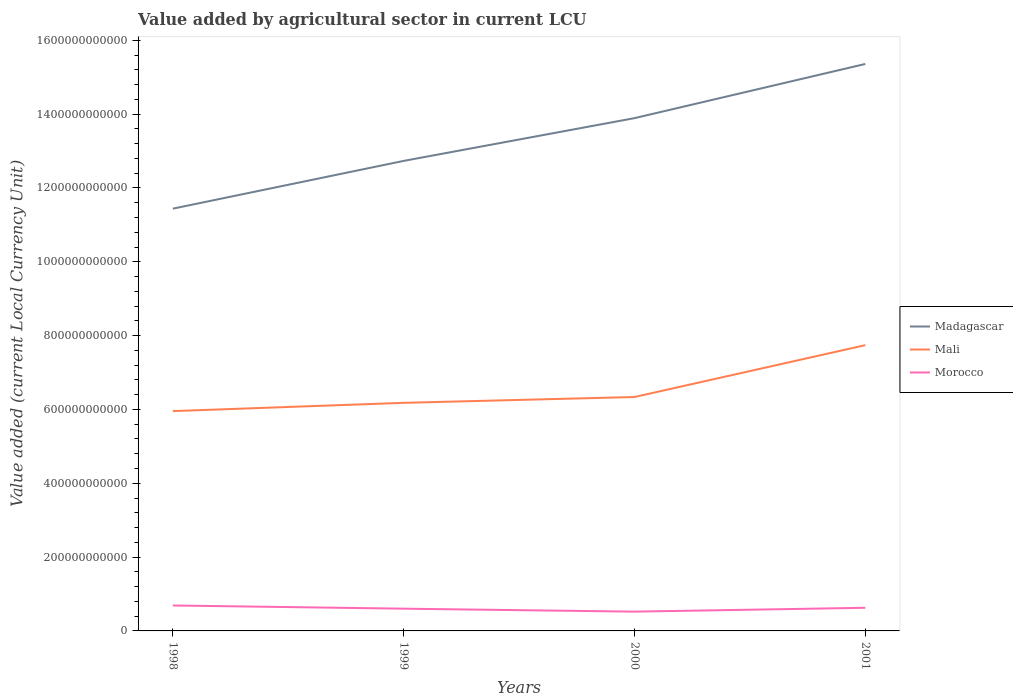Does the line corresponding to Morocco intersect with the line corresponding to Mali?
Make the answer very short. No. Across all years, what is the maximum value added by agricultural sector in Madagascar?
Your answer should be compact. 1.14e+12. In which year was the value added by agricultural sector in Madagascar maximum?
Provide a short and direct response. 1998. What is the total value added by agricultural sector in Morocco in the graph?
Provide a succinct answer. 1.67e+1. What is the difference between the highest and the second highest value added by agricultural sector in Mali?
Keep it short and to the point. 1.79e+11. What is the difference between the highest and the lowest value added by agricultural sector in Mali?
Keep it short and to the point. 1. Is the value added by agricultural sector in Madagascar strictly greater than the value added by agricultural sector in Mali over the years?
Your response must be concise. No. What is the difference between two consecutive major ticks on the Y-axis?
Your answer should be compact. 2.00e+11. Are the values on the major ticks of Y-axis written in scientific E-notation?
Keep it short and to the point. No. How many legend labels are there?
Make the answer very short. 3. What is the title of the graph?
Provide a short and direct response. Value added by agricultural sector in current LCU. Does "Cote d'Ivoire" appear as one of the legend labels in the graph?
Your answer should be very brief. No. What is the label or title of the X-axis?
Make the answer very short. Years. What is the label or title of the Y-axis?
Provide a short and direct response. Value added (current Local Currency Unit). What is the Value added (current Local Currency Unit) of Madagascar in 1998?
Your response must be concise. 1.14e+12. What is the Value added (current Local Currency Unit) in Mali in 1998?
Give a very brief answer. 5.95e+11. What is the Value added (current Local Currency Unit) of Morocco in 1998?
Give a very brief answer. 6.89e+1. What is the Value added (current Local Currency Unit) of Madagascar in 1999?
Your answer should be very brief. 1.27e+12. What is the Value added (current Local Currency Unit) in Mali in 1999?
Your response must be concise. 6.18e+11. What is the Value added (current Local Currency Unit) in Morocco in 1999?
Provide a succinct answer. 6.03e+1. What is the Value added (current Local Currency Unit) in Madagascar in 2000?
Make the answer very short. 1.39e+12. What is the Value added (current Local Currency Unit) of Mali in 2000?
Give a very brief answer. 6.34e+11. What is the Value added (current Local Currency Unit) of Morocco in 2000?
Provide a short and direct response. 5.22e+1. What is the Value added (current Local Currency Unit) of Madagascar in 2001?
Give a very brief answer. 1.54e+12. What is the Value added (current Local Currency Unit) of Mali in 2001?
Offer a very short reply. 7.74e+11. What is the Value added (current Local Currency Unit) in Morocco in 2001?
Ensure brevity in your answer.  6.27e+1. Across all years, what is the maximum Value added (current Local Currency Unit) in Madagascar?
Make the answer very short. 1.54e+12. Across all years, what is the maximum Value added (current Local Currency Unit) in Mali?
Your answer should be compact. 7.74e+11. Across all years, what is the maximum Value added (current Local Currency Unit) of Morocco?
Ensure brevity in your answer.  6.89e+1. Across all years, what is the minimum Value added (current Local Currency Unit) of Madagascar?
Your response must be concise. 1.14e+12. Across all years, what is the minimum Value added (current Local Currency Unit) in Mali?
Make the answer very short. 5.95e+11. Across all years, what is the minimum Value added (current Local Currency Unit) in Morocco?
Offer a terse response. 5.22e+1. What is the total Value added (current Local Currency Unit) in Madagascar in the graph?
Your response must be concise. 5.34e+12. What is the total Value added (current Local Currency Unit) of Mali in the graph?
Your answer should be compact. 2.62e+12. What is the total Value added (current Local Currency Unit) of Morocco in the graph?
Your response must be concise. 2.44e+11. What is the difference between the Value added (current Local Currency Unit) of Madagascar in 1998 and that in 1999?
Your response must be concise. -1.29e+11. What is the difference between the Value added (current Local Currency Unit) in Mali in 1998 and that in 1999?
Provide a succinct answer. -2.25e+1. What is the difference between the Value added (current Local Currency Unit) in Morocco in 1998 and that in 1999?
Keep it short and to the point. 8.63e+09. What is the difference between the Value added (current Local Currency Unit) in Madagascar in 1998 and that in 2000?
Give a very brief answer. -2.45e+11. What is the difference between the Value added (current Local Currency Unit) in Mali in 1998 and that in 2000?
Your answer should be very brief. -3.82e+1. What is the difference between the Value added (current Local Currency Unit) of Morocco in 1998 and that in 2000?
Provide a succinct answer. 1.67e+1. What is the difference between the Value added (current Local Currency Unit) of Madagascar in 1998 and that in 2001?
Your response must be concise. -3.92e+11. What is the difference between the Value added (current Local Currency Unit) of Mali in 1998 and that in 2001?
Your answer should be very brief. -1.79e+11. What is the difference between the Value added (current Local Currency Unit) in Morocco in 1998 and that in 2001?
Make the answer very short. 6.24e+09. What is the difference between the Value added (current Local Currency Unit) of Madagascar in 1999 and that in 2000?
Make the answer very short. -1.16e+11. What is the difference between the Value added (current Local Currency Unit) in Mali in 1999 and that in 2000?
Provide a succinct answer. -1.57e+1. What is the difference between the Value added (current Local Currency Unit) in Morocco in 1999 and that in 2000?
Ensure brevity in your answer.  8.05e+09. What is the difference between the Value added (current Local Currency Unit) of Madagascar in 1999 and that in 2001?
Your answer should be very brief. -2.63e+11. What is the difference between the Value added (current Local Currency Unit) in Mali in 1999 and that in 2001?
Your answer should be compact. -1.56e+11. What is the difference between the Value added (current Local Currency Unit) in Morocco in 1999 and that in 2001?
Give a very brief answer. -2.39e+09. What is the difference between the Value added (current Local Currency Unit) of Madagascar in 2000 and that in 2001?
Ensure brevity in your answer.  -1.47e+11. What is the difference between the Value added (current Local Currency Unit) of Mali in 2000 and that in 2001?
Offer a very short reply. -1.40e+11. What is the difference between the Value added (current Local Currency Unit) of Morocco in 2000 and that in 2001?
Offer a very short reply. -1.04e+1. What is the difference between the Value added (current Local Currency Unit) in Madagascar in 1998 and the Value added (current Local Currency Unit) in Mali in 1999?
Provide a succinct answer. 5.26e+11. What is the difference between the Value added (current Local Currency Unit) in Madagascar in 1998 and the Value added (current Local Currency Unit) in Morocco in 1999?
Offer a terse response. 1.08e+12. What is the difference between the Value added (current Local Currency Unit) of Mali in 1998 and the Value added (current Local Currency Unit) of Morocco in 1999?
Your answer should be compact. 5.35e+11. What is the difference between the Value added (current Local Currency Unit) of Madagascar in 1998 and the Value added (current Local Currency Unit) of Mali in 2000?
Provide a short and direct response. 5.10e+11. What is the difference between the Value added (current Local Currency Unit) in Madagascar in 1998 and the Value added (current Local Currency Unit) in Morocco in 2000?
Your response must be concise. 1.09e+12. What is the difference between the Value added (current Local Currency Unit) of Mali in 1998 and the Value added (current Local Currency Unit) of Morocco in 2000?
Offer a terse response. 5.43e+11. What is the difference between the Value added (current Local Currency Unit) in Madagascar in 1998 and the Value added (current Local Currency Unit) in Mali in 2001?
Your answer should be compact. 3.70e+11. What is the difference between the Value added (current Local Currency Unit) of Madagascar in 1998 and the Value added (current Local Currency Unit) of Morocco in 2001?
Ensure brevity in your answer.  1.08e+12. What is the difference between the Value added (current Local Currency Unit) in Mali in 1998 and the Value added (current Local Currency Unit) in Morocco in 2001?
Provide a succinct answer. 5.33e+11. What is the difference between the Value added (current Local Currency Unit) of Madagascar in 1999 and the Value added (current Local Currency Unit) of Mali in 2000?
Offer a terse response. 6.40e+11. What is the difference between the Value added (current Local Currency Unit) of Madagascar in 1999 and the Value added (current Local Currency Unit) of Morocco in 2000?
Offer a terse response. 1.22e+12. What is the difference between the Value added (current Local Currency Unit) in Mali in 1999 and the Value added (current Local Currency Unit) in Morocco in 2000?
Offer a very short reply. 5.66e+11. What is the difference between the Value added (current Local Currency Unit) of Madagascar in 1999 and the Value added (current Local Currency Unit) of Mali in 2001?
Your answer should be compact. 4.99e+11. What is the difference between the Value added (current Local Currency Unit) in Madagascar in 1999 and the Value added (current Local Currency Unit) in Morocco in 2001?
Offer a very short reply. 1.21e+12. What is the difference between the Value added (current Local Currency Unit) of Mali in 1999 and the Value added (current Local Currency Unit) of Morocco in 2001?
Make the answer very short. 5.55e+11. What is the difference between the Value added (current Local Currency Unit) in Madagascar in 2000 and the Value added (current Local Currency Unit) in Mali in 2001?
Your response must be concise. 6.15e+11. What is the difference between the Value added (current Local Currency Unit) of Madagascar in 2000 and the Value added (current Local Currency Unit) of Morocco in 2001?
Keep it short and to the point. 1.33e+12. What is the difference between the Value added (current Local Currency Unit) of Mali in 2000 and the Value added (current Local Currency Unit) of Morocco in 2001?
Keep it short and to the point. 5.71e+11. What is the average Value added (current Local Currency Unit) in Madagascar per year?
Provide a succinct answer. 1.34e+12. What is the average Value added (current Local Currency Unit) of Mali per year?
Offer a terse response. 6.55e+11. What is the average Value added (current Local Currency Unit) of Morocco per year?
Make the answer very short. 6.10e+1. In the year 1998, what is the difference between the Value added (current Local Currency Unit) in Madagascar and Value added (current Local Currency Unit) in Mali?
Your answer should be compact. 5.48e+11. In the year 1998, what is the difference between the Value added (current Local Currency Unit) of Madagascar and Value added (current Local Currency Unit) of Morocco?
Make the answer very short. 1.07e+12. In the year 1998, what is the difference between the Value added (current Local Currency Unit) in Mali and Value added (current Local Currency Unit) in Morocco?
Your answer should be compact. 5.27e+11. In the year 1999, what is the difference between the Value added (current Local Currency Unit) in Madagascar and Value added (current Local Currency Unit) in Mali?
Your answer should be compact. 6.55e+11. In the year 1999, what is the difference between the Value added (current Local Currency Unit) of Madagascar and Value added (current Local Currency Unit) of Morocco?
Give a very brief answer. 1.21e+12. In the year 1999, what is the difference between the Value added (current Local Currency Unit) in Mali and Value added (current Local Currency Unit) in Morocco?
Offer a terse response. 5.58e+11. In the year 2000, what is the difference between the Value added (current Local Currency Unit) in Madagascar and Value added (current Local Currency Unit) in Mali?
Offer a terse response. 7.55e+11. In the year 2000, what is the difference between the Value added (current Local Currency Unit) of Madagascar and Value added (current Local Currency Unit) of Morocco?
Offer a terse response. 1.34e+12. In the year 2000, what is the difference between the Value added (current Local Currency Unit) in Mali and Value added (current Local Currency Unit) in Morocco?
Keep it short and to the point. 5.81e+11. In the year 2001, what is the difference between the Value added (current Local Currency Unit) in Madagascar and Value added (current Local Currency Unit) in Mali?
Provide a succinct answer. 7.62e+11. In the year 2001, what is the difference between the Value added (current Local Currency Unit) in Madagascar and Value added (current Local Currency Unit) in Morocco?
Make the answer very short. 1.47e+12. In the year 2001, what is the difference between the Value added (current Local Currency Unit) in Mali and Value added (current Local Currency Unit) in Morocco?
Ensure brevity in your answer.  7.11e+11. What is the ratio of the Value added (current Local Currency Unit) of Madagascar in 1998 to that in 1999?
Keep it short and to the point. 0.9. What is the ratio of the Value added (current Local Currency Unit) of Mali in 1998 to that in 1999?
Your response must be concise. 0.96. What is the ratio of the Value added (current Local Currency Unit) in Morocco in 1998 to that in 1999?
Keep it short and to the point. 1.14. What is the ratio of the Value added (current Local Currency Unit) in Madagascar in 1998 to that in 2000?
Your answer should be very brief. 0.82. What is the ratio of the Value added (current Local Currency Unit) in Mali in 1998 to that in 2000?
Give a very brief answer. 0.94. What is the ratio of the Value added (current Local Currency Unit) of Morocco in 1998 to that in 2000?
Your response must be concise. 1.32. What is the ratio of the Value added (current Local Currency Unit) of Madagascar in 1998 to that in 2001?
Ensure brevity in your answer.  0.74. What is the ratio of the Value added (current Local Currency Unit) of Mali in 1998 to that in 2001?
Offer a very short reply. 0.77. What is the ratio of the Value added (current Local Currency Unit) of Morocco in 1998 to that in 2001?
Your response must be concise. 1.1. What is the ratio of the Value added (current Local Currency Unit) in Madagascar in 1999 to that in 2000?
Your answer should be compact. 0.92. What is the ratio of the Value added (current Local Currency Unit) of Mali in 1999 to that in 2000?
Provide a short and direct response. 0.98. What is the ratio of the Value added (current Local Currency Unit) in Morocco in 1999 to that in 2000?
Your answer should be very brief. 1.15. What is the ratio of the Value added (current Local Currency Unit) of Madagascar in 1999 to that in 2001?
Ensure brevity in your answer.  0.83. What is the ratio of the Value added (current Local Currency Unit) in Mali in 1999 to that in 2001?
Offer a very short reply. 0.8. What is the ratio of the Value added (current Local Currency Unit) in Morocco in 1999 to that in 2001?
Provide a succinct answer. 0.96. What is the ratio of the Value added (current Local Currency Unit) of Madagascar in 2000 to that in 2001?
Give a very brief answer. 0.9. What is the ratio of the Value added (current Local Currency Unit) in Mali in 2000 to that in 2001?
Ensure brevity in your answer.  0.82. What is the ratio of the Value added (current Local Currency Unit) in Morocco in 2000 to that in 2001?
Make the answer very short. 0.83. What is the difference between the highest and the second highest Value added (current Local Currency Unit) of Madagascar?
Give a very brief answer. 1.47e+11. What is the difference between the highest and the second highest Value added (current Local Currency Unit) in Mali?
Ensure brevity in your answer.  1.40e+11. What is the difference between the highest and the second highest Value added (current Local Currency Unit) in Morocco?
Your response must be concise. 6.24e+09. What is the difference between the highest and the lowest Value added (current Local Currency Unit) of Madagascar?
Your response must be concise. 3.92e+11. What is the difference between the highest and the lowest Value added (current Local Currency Unit) of Mali?
Provide a succinct answer. 1.79e+11. What is the difference between the highest and the lowest Value added (current Local Currency Unit) of Morocco?
Make the answer very short. 1.67e+1. 